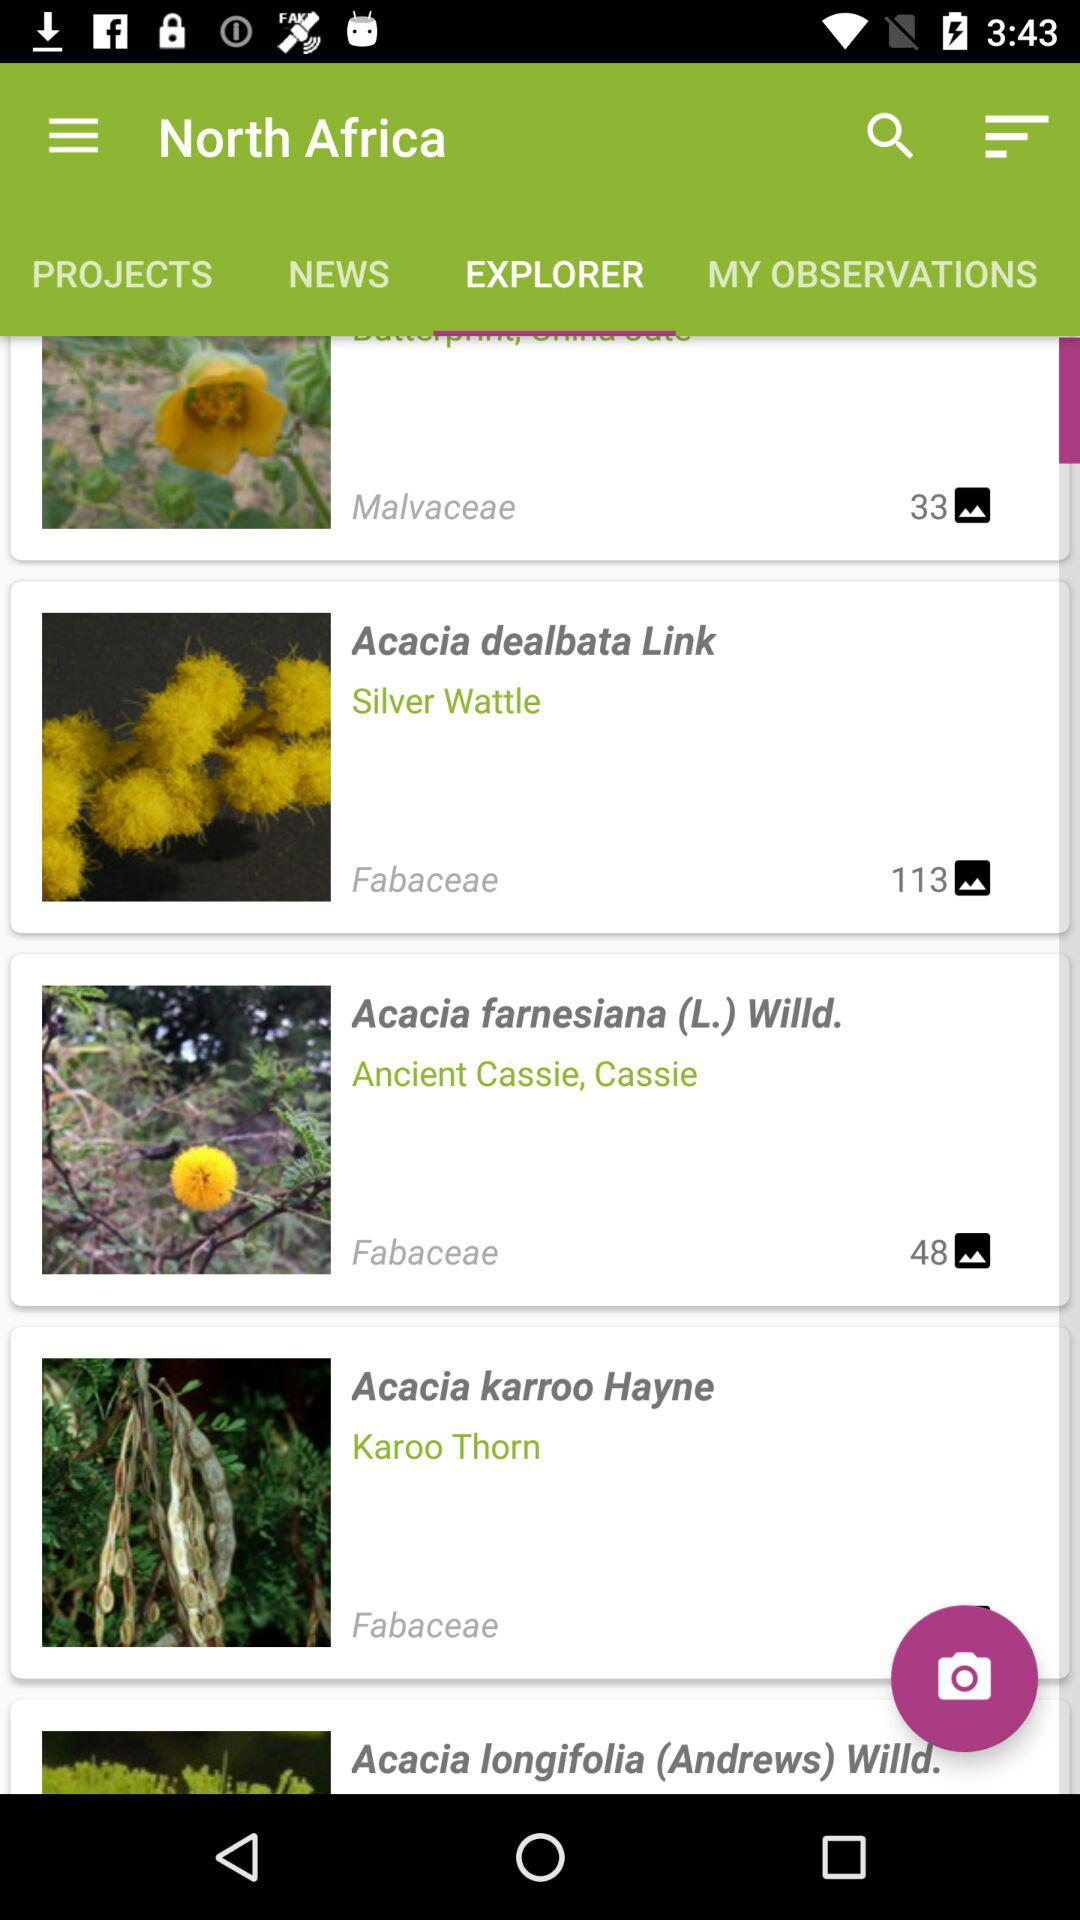What information can you find about Acacia dealbata on this app? The 'Acacia dealbata,' also known as Silver Wattle, is listed under the family Fabaceae. The app likely provides in-depth details including its botanical characteristics, native habitat, and uses. You might also find user-uploaded images and observations which can offer more insights into how the plant looks in different seasons and environments. 